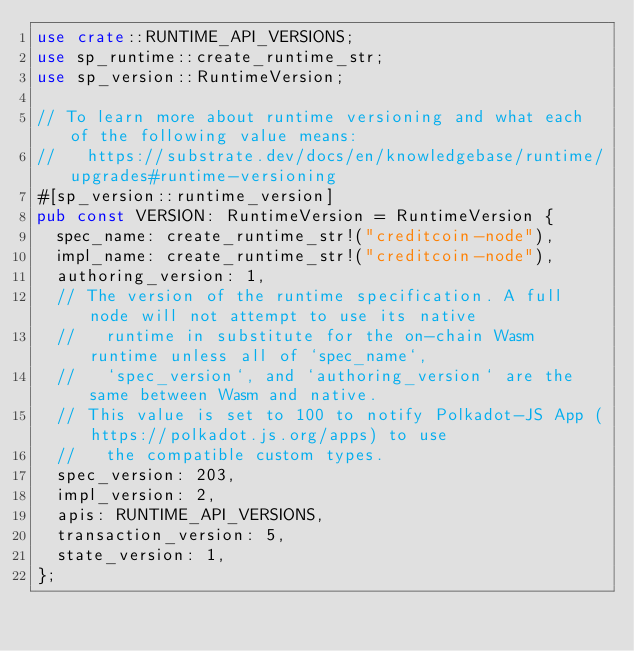Convert code to text. <code><loc_0><loc_0><loc_500><loc_500><_Rust_>use crate::RUNTIME_API_VERSIONS;
use sp_runtime::create_runtime_str;
use sp_version::RuntimeVersion;

// To learn more about runtime versioning and what each of the following value means:
//   https://substrate.dev/docs/en/knowledgebase/runtime/upgrades#runtime-versioning
#[sp_version::runtime_version]
pub const VERSION: RuntimeVersion = RuntimeVersion {
	spec_name: create_runtime_str!("creditcoin-node"),
	impl_name: create_runtime_str!("creditcoin-node"),
	authoring_version: 1,
	// The version of the runtime specification. A full node will not attempt to use its native
	//   runtime in substitute for the on-chain Wasm runtime unless all of `spec_name`,
	//   `spec_version`, and `authoring_version` are the same between Wasm and native.
	// This value is set to 100 to notify Polkadot-JS App (https://polkadot.js.org/apps) to use
	//   the compatible custom types.
	spec_version: 203,
	impl_version: 2,
	apis: RUNTIME_API_VERSIONS,
	transaction_version: 5,
	state_version: 1,
};
</code> 